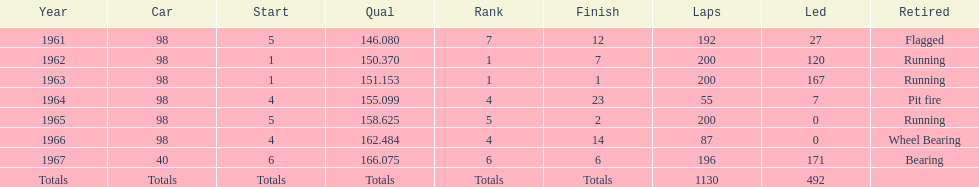In how many indy 500 events, has jones received flags? 1. 